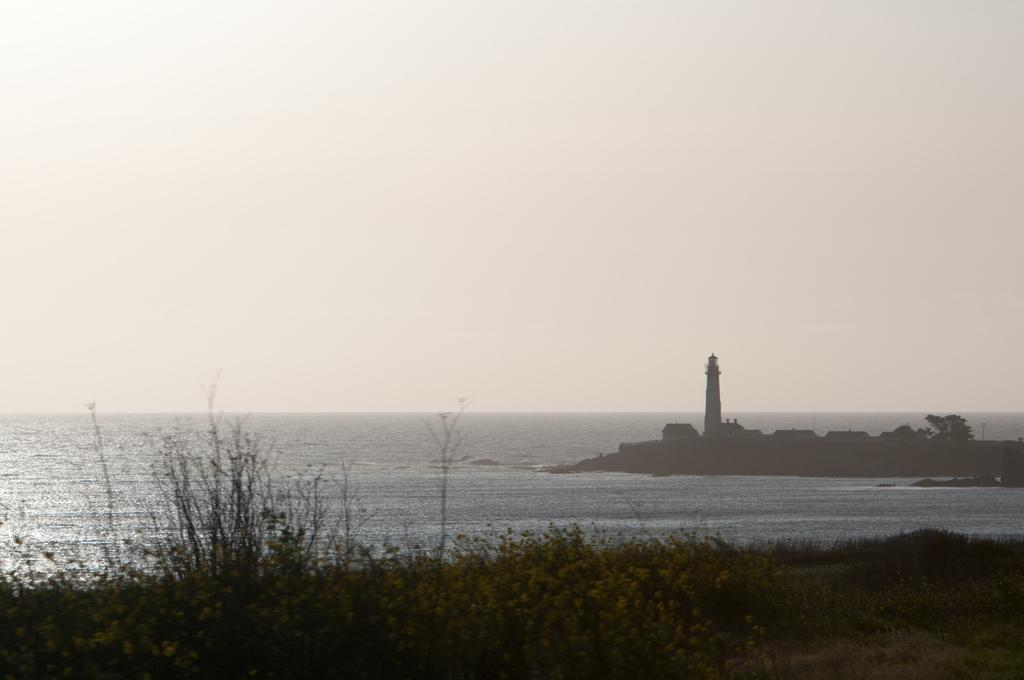What is the main structure in the image? There is a lighthouse in the image. What type of buildings can be seen near the lighthouse? There are houses on the sea shore in the image. What type of vegetation is present in the image? There are plants and bushes in the image. What is visible above the land and sea in the image? The sky is visible in the image. How does the wren use its impulse to fly in the image? There is no wren present in the image, so it is not possible to answer that question. 